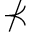<formula> <loc_0><loc_0><loc_500><loc_500>\nprec</formula> 